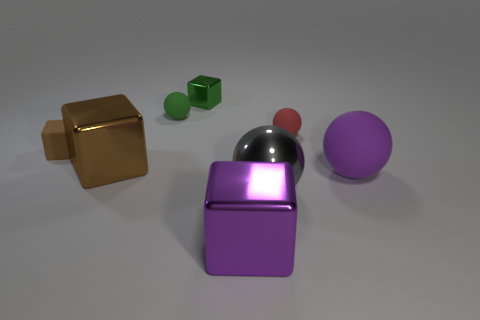What number of matte spheres are right of the big purple metal cube and on the left side of the purple block?
Give a very brief answer. 0. What number of other things are there of the same material as the small brown thing
Your answer should be compact. 3. The large sphere that is on the left side of the object that is on the right side of the tiny red rubber object is what color?
Ensure brevity in your answer.  Gray. There is a sphere to the left of the big gray sphere; is its color the same as the large rubber sphere?
Offer a very short reply. No. Is the size of the green ball the same as the purple shiny block?
Make the answer very short. No. There is another purple thing that is the same size as the purple metallic object; what shape is it?
Your response must be concise. Sphere. There is a metal cube that is in front of the purple matte object; does it have the same size as the small green matte sphere?
Provide a short and direct response. No. There is a cube that is the same size as the brown matte object; what is its material?
Keep it short and to the point. Metal. Is there a gray sphere that is left of the large block that is to the left of the big purple object to the left of the large purple rubber thing?
Provide a short and direct response. No. Are there any other things that are the same shape as the purple metal object?
Offer a very short reply. Yes. 